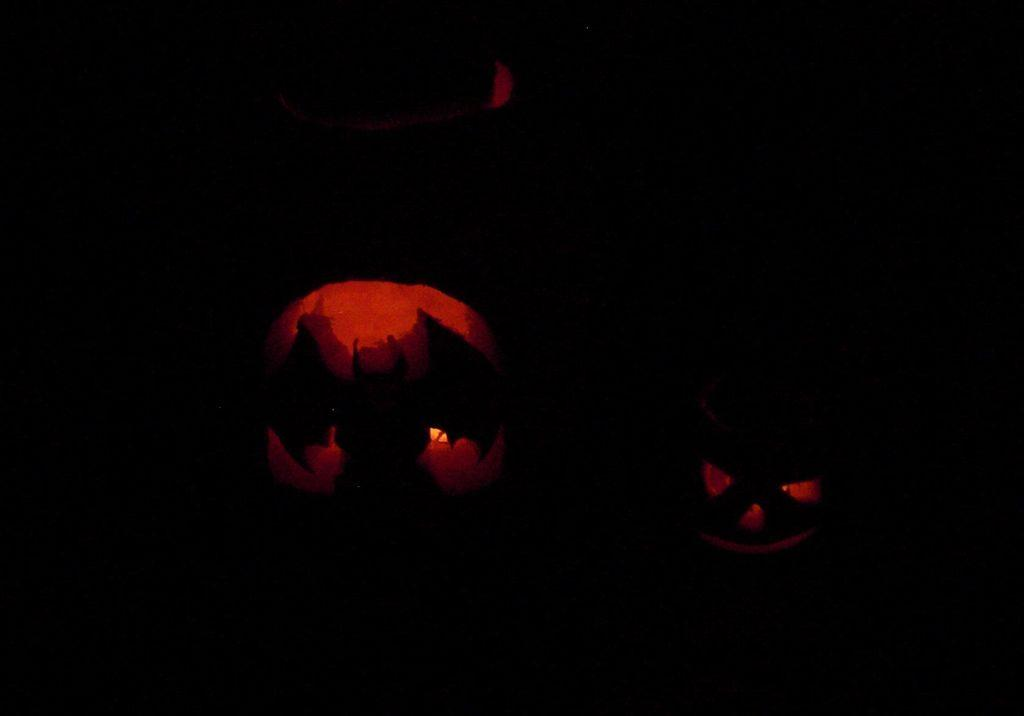What type of shadow is visible in the image? There is a bat shadow in the image. What color are the lights on the bat shadow? The bat shadow has red lights. What other image is present in the image? There is a devil image in the image. What color is the light on the devil image? The devil image has red light. What color is the background of the image? The background of the image is black. How many chickens are present in the image? There are no chickens present in the image. Is there any blood visible in the image? There is no blood visible in the image. What type of metal is used to make the devil's pitchfork in the image? There is no pitchfork present in the image, so it is not possible to determine the type of metal used. 